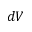Convert formula to latex. <formula><loc_0><loc_0><loc_500><loc_500>d V</formula> 